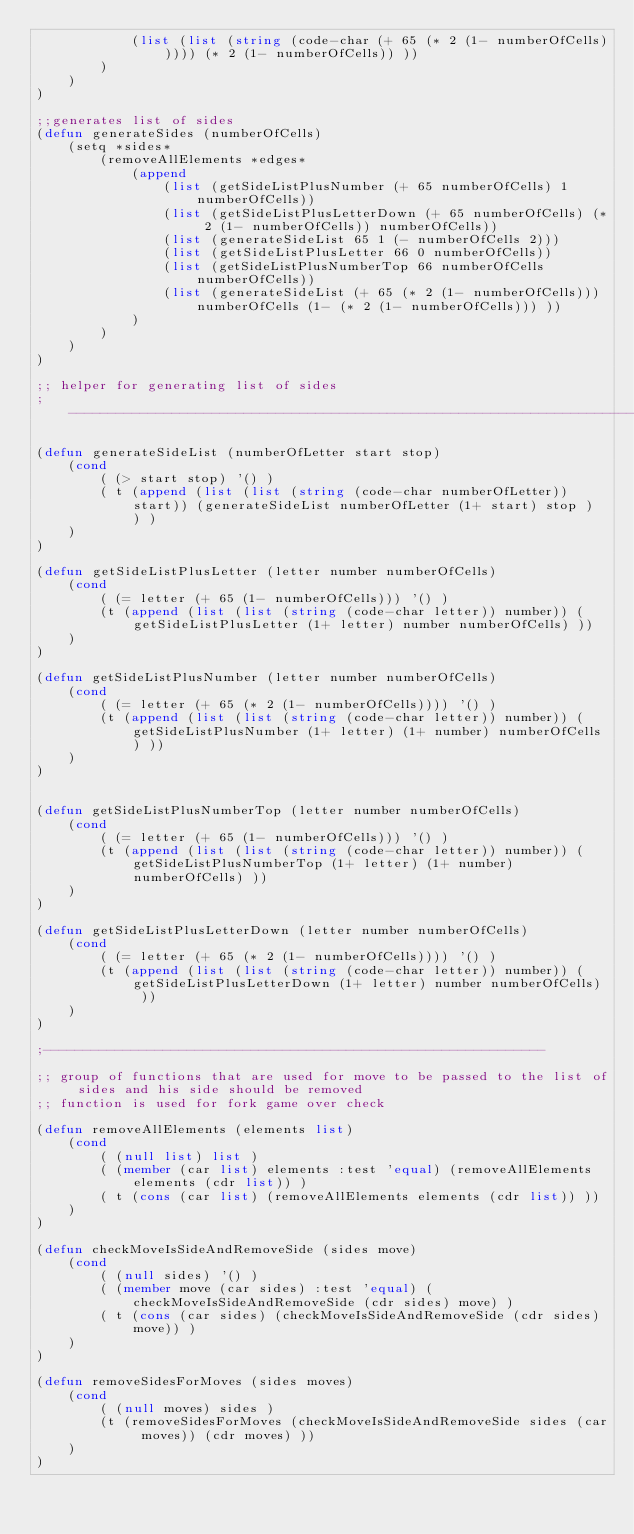Convert code to text. <code><loc_0><loc_0><loc_500><loc_500><_Lisp_>            (list (list (string (code-char (+ 65 (* 2 (1- numberOfCells))))) (* 2 (1- numberOfCells)) ))
        )
    )
)

;;generates list of sides
(defun generateSides (numberOfCells)
    (setq *sides* 
        (removeAllElements *edges*
            (append
                (list (getSideListPlusNumber (+ 65 numberOfCells) 1 numberOfCells))
                (list (getSideListPlusLetterDown (+ 65 numberOfCells) (* 2 (1- numberOfCells)) numberOfCells))
                (list (generateSideList 65 1 (- numberOfCells 2)))
                (list (getSideListPlusLetter 66 0 numberOfCells))
                (list (getSideListPlusNumberTop 66 numberOfCells numberOfCells))
                (list (generateSideList (+ 65 (* 2 (1- numberOfCells))) numberOfCells (1- (* 2 (1- numberOfCells))) ))
            )
        )
    )
)

;; helper for generating list of sides
;---------------------------------------------------------------------------

(defun generateSideList (numberOfLetter start stop)
    (cond
        ( (> start stop) '() )
        ( t (append (list (list (string (code-char numberOfLetter)) start)) (generateSideList numberOfLetter (1+ start) stop ) ) )
    )
)

(defun getSideListPlusLetter (letter number numberOfCells)
    (cond
        ( (= letter (+ 65 (1- numberOfCells))) '() )
        (t (append (list (list (string (code-char letter)) number)) (getSideListPlusLetter (1+ letter) number numberOfCells) ))
    )
)

(defun getSideListPlusNumber (letter number numberOfCells)
    (cond
        ( (= letter (+ 65 (* 2 (1- numberOfCells)))) '() )
        (t (append (list (list (string (code-char letter)) number)) (getSideListPlusNumber (1+ letter) (1+ number) numberOfCells) ))
    )
)


(defun getSideListPlusNumberTop (letter number numberOfCells)
    (cond
        ( (= letter (+ 65 (1- numberOfCells))) '() )
        (t (append (list (list (string (code-char letter)) number)) (getSideListPlusNumberTop (1+ letter) (1+ number) numberOfCells) ))
    )
)

(defun getSideListPlusLetterDown (letter number numberOfCells)
    (cond
        ( (= letter (+ 65 (* 2 (1- numberOfCells)))) '() )
        (t (append (list (list (string (code-char letter)) number)) (getSideListPlusLetterDown (1+ letter) number numberOfCells) ))
    )
)

;---------------------------------------------------------------

;; group of functions that are used for move to be passed to the list of sides and his side should be removed
;; function is used for fork game over check

(defun removeAllElements (elements list)
    (cond
        ( (null list) list )
        ( (member (car list) elements :test 'equal) (removeAllElements elements (cdr list)) )
        ( t (cons (car list) (removeAllElements elements (cdr list)) ))
    )
)

(defun checkMoveIsSideAndRemoveSide (sides move)
    (cond
        ( (null sides) '() )
        ( (member move (car sides) :test 'equal) (checkMoveIsSideAndRemoveSide (cdr sides) move) )
        ( t (cons (car sides) (checkMoveIsSideAndRemoveSide (cdr sides) move)) )
    )
)

(defun removeSidesForMoves (sides moves)
    (cond
        ( (null moves) sides )
        (t (removeSidesForMoves (checkMoveIsSideAndRemoveSide sides (car moves)) (cdr moves) ))
    )
)</code> 